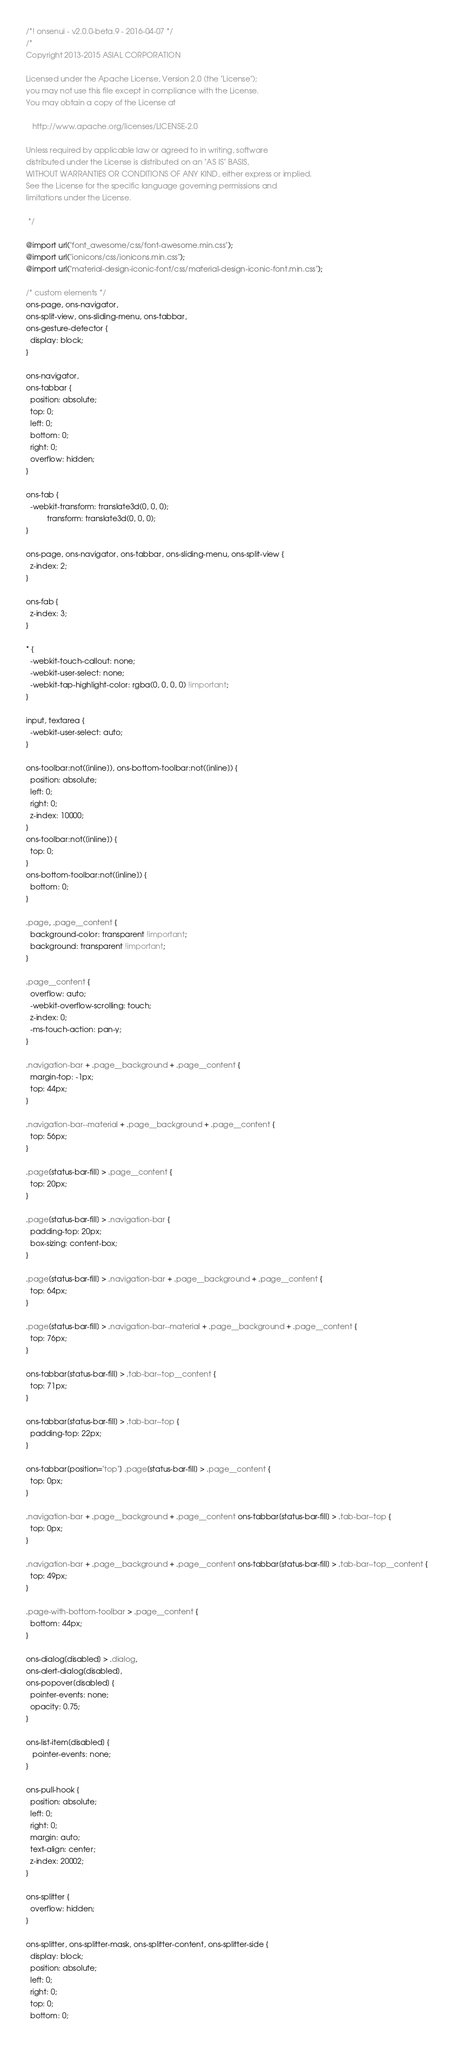Convert code to text. <code><loc_0><loc_0><loc_500><loc_500><_CSS_>/*! onsenui - v2.0.0-beta.9 - 2016-04-07 */
/*
Copyright 2013-2015 ASIAL CORPORATION

Licensed under the Apache License, Version 2.0 (the "License");
you may not use this file except in compliance with the License.
You may obtain a copy of the License at

   http://www.apache.org/licenses/LICENSE-2.0

Unless required by applicable law or agreed to in writing, software
distributed under the License is distributed on an "AS IS" BASIS,
WITHOUT WARRANTIES OR CONDITIONS OF ANY KIND, either express or implied.
See the License for the specific language governing permissions and
limitations under the License.

 */

@import url("font_awesome/css/font-awesome.min.css");
@import url("ionicons/css/ionicons.min.css");
@import url("material-design-iconic-font/css/material-design-iconic-font.min.css");

/* custom elements */
ons-page, ons-navigator,
ons-split-view, ons-sliding-menu, ons-tabbar,
ons-gesture-detector {
  display: block;
}

ons-navigator,
ons-tabbar {
  position: absolute;
  top: 0;
  left: 0;
  bottom: 0;
  right: 0;
  overflow: hidden;
}

ons-tab {
  -webkit-transform: translate3d(0, 0, 0);
          transform: translate3d(0, 0, 0);
}

ons-page, ons-navigator, ons-tabbar, ons-sliding-menu, ons-split-view {
  z-index: 2;
}

ons-fab {
  z-index: 3;
}

* {
  -webkit-touch-callout: none;
  -webkit-user-select: none;
  -webkit-tap-highlight-color: rgba(0, 0, 0, 0) !important;
}

input, textarea {
  -webkit-user-select: auto;
}

ons-toolbar:not([inline]), ons-bottom-toolbar:not([inline]) {
  position: absolute;
  left: 0;
  right: 0;
  z-index: 10000;
}
ons-toolbar:not([inline]) {
  top: 0;
}
ons-bottom-toolbar:not([inline]) {
  bottom: 0;
}

.page, .page__content {
  background-color: transparent !important;
  background: transparent !important;
}

.page__content {
  overflow: auto;
  -webkit-overflow-scrolling: touch;
  z-index: 0;
  -ms-touch-action: pan-y;
}

.navigation-bar + .page__background + .page__content {
  margin-top: -1px;
  top: 44px;
}

.navigation-bar--material + .page__background + .page__content {
  top: 56px;
}

.page[status-bar-fill] > .page__content {
  top: 20px;
}

.page[status-bar-fill] > .navigation-bar {
  padding-top: 20px;
  box-sizing: content-box;
}

.page[status-bar-fill] > .navigation-bar + .page__background + .page__content {
  top: 64px;
}

.page[status-bar-fill] > .navigation-bar--material + .page__background + .page__content {
  top: 76px;
}

ons-tabbar[status-bar-fill] > .tab-bar--top__content {
  top: 71px;
}

ons-tabbar[status-bar-fill] > .tab-bar--top {
  padding-top: 22px;
}

ons-tabbar[position="top"] .page[status-bar-fill] > .page__content {
  top: 0px;
}

.navigation-bar + .page__background + .page__content ons-tabbar[status-bar-fill] > .tab-bar--top {
  top: 0px;
}

.navigation-bar + .page__background + .page__content ons-tabbar[status-bar-fill] > .tab-bar--top__content {
  top: 49px;
}

.page-with-bottom-toolbar > .page__content {
  bottom: 44px;
}

ons-dialog[disabled] > .dialog,
ons-alert-dialog[disabled],
ons-popover[disabled] {
  pointer-events: none;
  opacity: 0.75;
}

ons-list-item[disabled] {
   pointer-events: none;
}

ons-pull-hook {
  position: absolute;
  left: 0;
  right: 0;
  margin: auto;
  text-align: center;
  z-index: 20002;
}

ons-splitter {
  overflow: hidden;
}

ons-splitter, ons-splitter-mask, ons-splitter-content, ons-splitter-side {
  display: block;
  position: absolute;
  left: 0;
  right: 0;
  top: 0;
  bottom: 0;</code> 